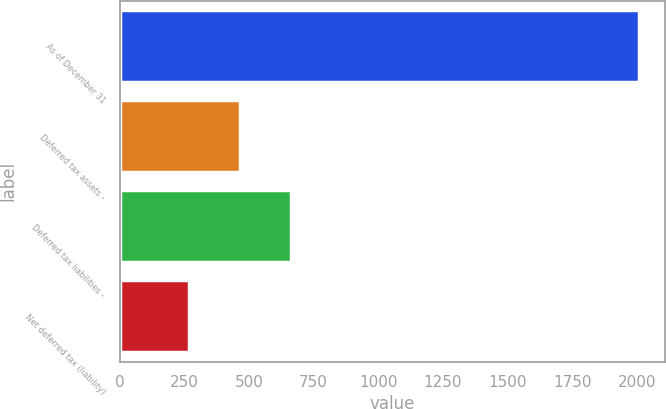<chart> <loc_0><loc_0><loc_500><loc_500><bar_chart><fcel>As of December 31<fcel>Deferred tax assets -<fcel>Deferred tax liabilities -<fcel>Net deferred tax (liability)<nl><fcel>2010<fcel>465<fcel>663<fcel>267<nl></chart> 